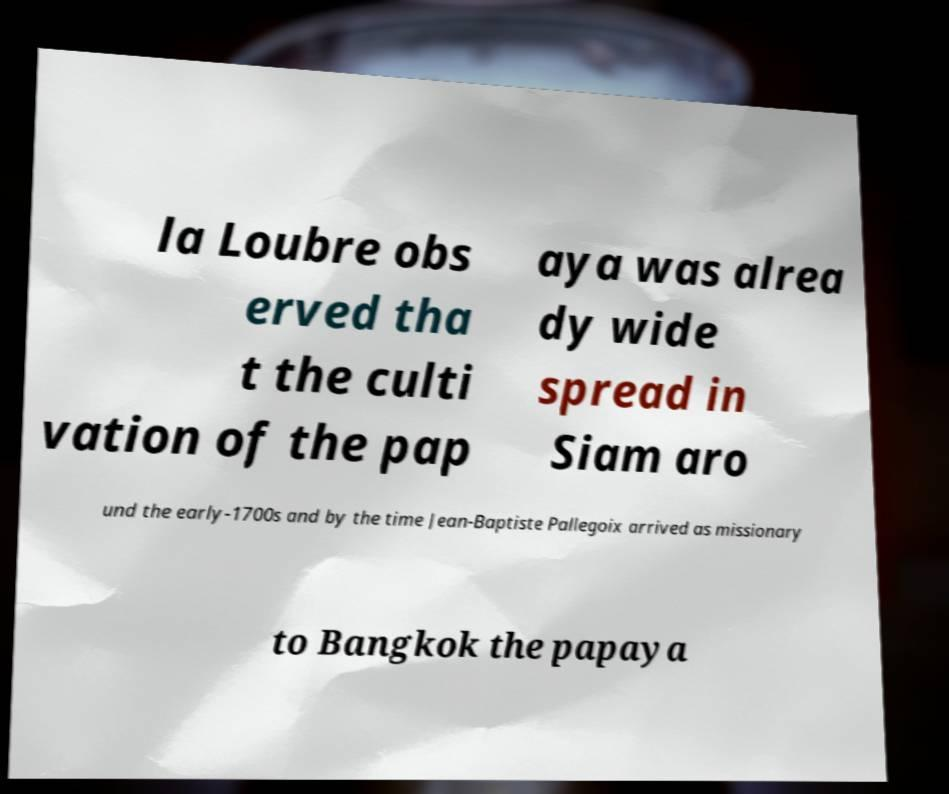Could you assist in decoding the text presented in this image and type it out clearly? la Loubre obs erved tha t the culti vation of the pap aya was alrea dy wide spread in Siam aro und the early-1700s and by the time Jean-Baptiste Pallegoix arrived as missionary to Bangkok the papaya 